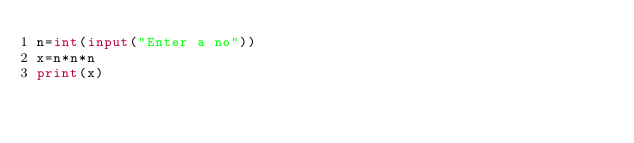<code> <loc_0><loc_0><loc_500><loc_500><_Python_>n=int(input("Enter a no"))
x=n*n*n
print(x)
</code> 